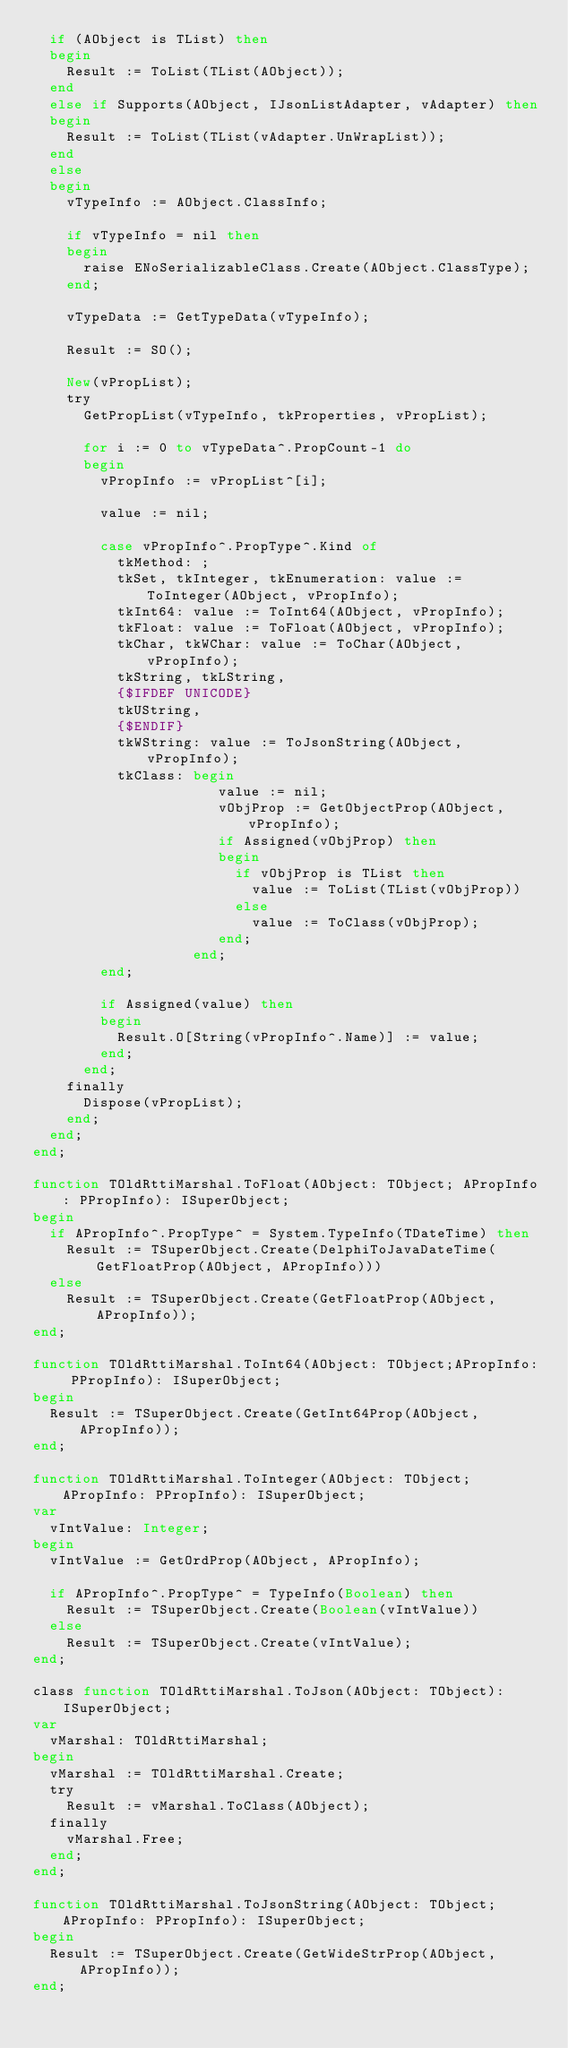<code> <loc_0><loc_0><loc_500><loc_500><_Pascal_>  if (AObject is TList) then
  begin
    Result := ToList(TList(AObject));
  end
  else if Supports(AObject, IJsonListAdapter, vAdapter) then
  begin
    Result := ToList(TList(vAdapter.UnWrapList));
  end
  else
  begin
    vTypeInfo := AObject.ClassInfo;

    if vTypeInfo = nil then
    begin
      raise ENoSerializableClass.Create(AObject.ClassType);
    end;

    vTypeData := GetTypeData(vTypeInfo);

    Result := SO();

    New(vPropList);
    try
      GetPropList(vTypeInfo, tkProperties, vPropList);

      for i := 0 to vTypeData^.PropCount-1 do
      begin
        vPropInfo := vPropList^[i];

        value := nil;

        case vPropInfo^.PropType^.Kind of
          tkMethod: ;
          tkSet, tkInteger, tkEnumeration: value := ToInteger(AObject, vPropInfo);
          tkInt64: value := ToInt64(AObject, vPropInfo);
          tkFloat: value := ToFloat(AObject, vPropInfo);
          tkChar, tkWChar: value := ToChar(AObject, vPropInfo); 
          tkString, tkLString,
          {$IFDEF UNICODE}
          tkUString,
          {$ENDIF}
          tkWString: value := ToJsonString(AObject, vPropInfo);
          tkClass: begin
                      value := nil;
                      vObjProp := GetObjectProp(AObject, vPropInfo);
                      if Assigned(vObjProp) then
                      begin
                        if vObjProp is TList then
                          value := ToList(TList(vObjProp))
                        else
                          value := ToClass(vObjProp);
                      end;
                   end;
        end;

        if Assigned(value) then
        begin
          Result.O[String(vPropInfo^.Name)] := value;
        end;
      end;
    finally
      Dispose(vPropList);
    end;
  end;
end;

function TOldRttiMarshal.ToFloat(AObject: TObject; APropInfo: PPropInfo): ISuperObject;
begin
  if APropInfo^.PropType^ = System.TypeInfo(TDateTime) then
    Result := TSuperObject.Create(DelphiToJavaDateTime(GetFloatProp(AObject, APropInfo)))
  else
    Result := TSuperObject.Create(GetFloatProp(AObject, APropInfo));
end;

function TOldRttiMarshal.ToInt64(AObject: TObject;APropInfo: PPropInfo): ISuperObject;
begin
  Result := TSuperObject.Create(GetInt64Prop(AObject, APropInfo));
end;

function TOldRttiMarshal.ToInteger(AObject: TObject; APropInfo: PPropInfo): ISuperObject;
var
  vIntValue: Integer;
begin
  vIntValue := GetOrdProp(AObject, APropInfo);

  if APropInfo^.PropType^ = TypeInfo(Boolean) then
    Result := TSuperObject.Create(Boolean(vIntValue))
  else
    Result := TSuperObject.Create(vIntValue);
end;

class function TOldRttiMarshal.ToJson(AObject: TObject): ISuperObject;
var
  vMarshal: TOldRttiMarshal;
begin
  vMarshal := TOldRttiMarshal.Create;
  try
    Result := vMarshal.ToClass(AObject);
  finally
    vMarshal.Free;
  end;
end;

function TOldRttiMarshal.ToJsonString(AObject: TObject;APropInfo: PPropInfo): ISuperObject;
begin
  Result := TSuperObject.Create(GetWideStrProp(AObject, APropInfo));
end;
</code> 